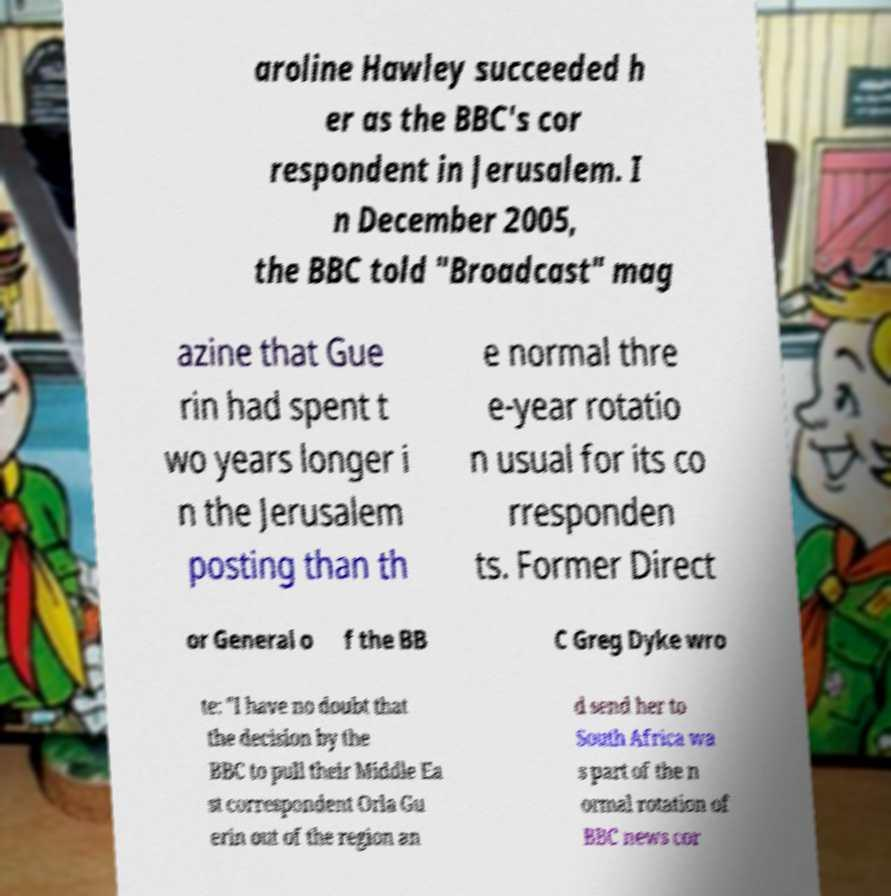Can you read and provide the text displayed in the image?This photo seems to have some interesting text. Can you extract and type it out for me? aroline Hawley succeeded h er as the BBC's cor respondent in Jerusalem. I n December 2005, the BBC told "Broadcast" mag azine that Gue rin had spent t wo years longer i n the Jerusalem posting than th e normal thre e-year rotatio n usual for its co rresponden ts. Former Direct or General o f the BB C Greg Dyke wro te: "I have no doubt that the decision by the BBC to pull their Middle Ea st correspondent Orla Gu erin out of the region an d send her to South Africa wa s part of the n ormal rotation of BBC news cor 